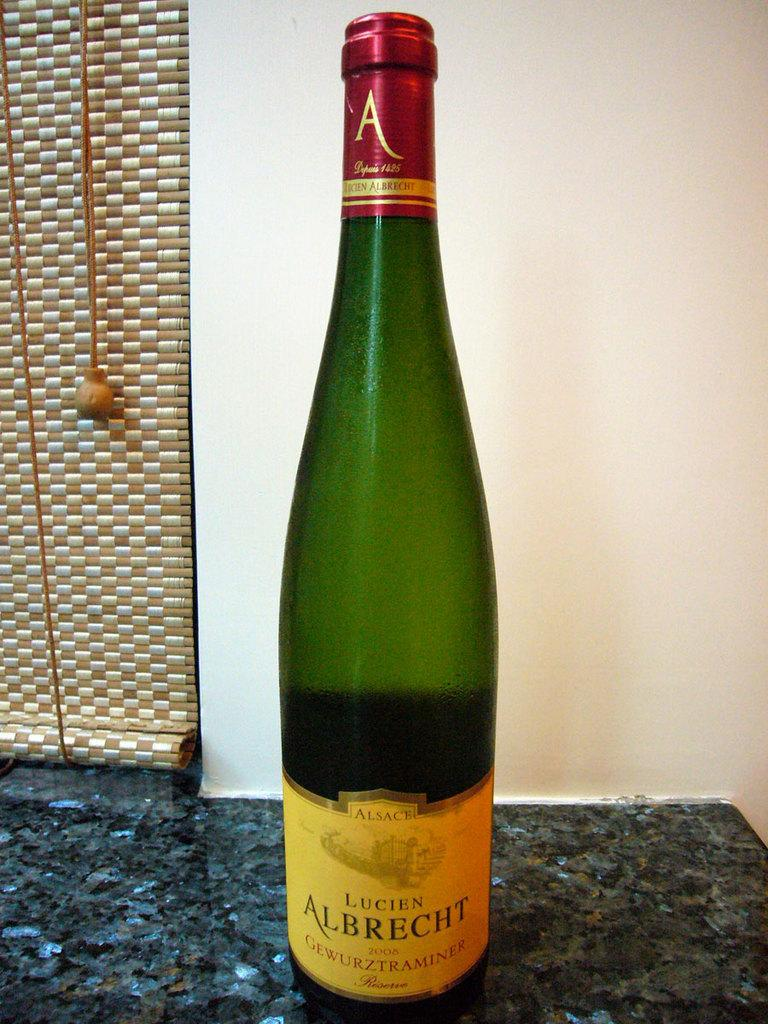<image>
Offer a succinct explanation of the picture presented. A green bottle of Lucien Albrecht on a counter. 